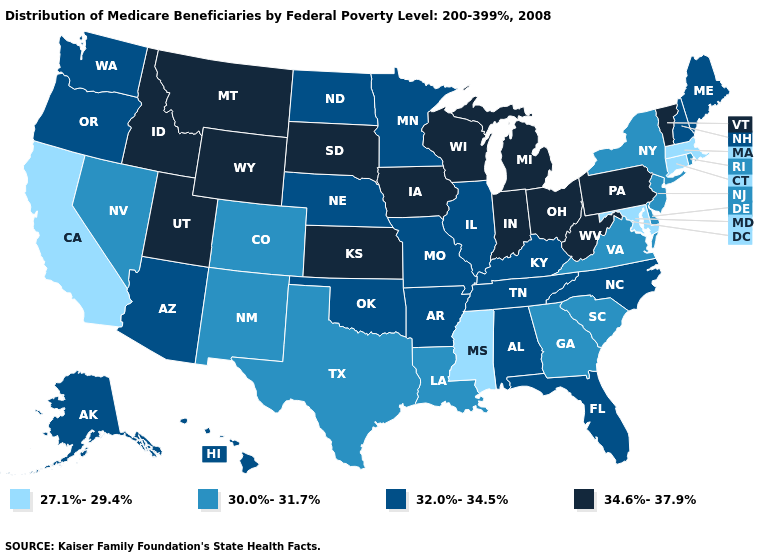What is the value of California?
Quick response, please. 27.1%-29.4%. Does Colorado have the highest value in the West?
Keep it brief. No. Which states have the lowest value in the USA?
Be succinct. California, Connecticut, Maryland, Massachusetts, Mississippi. Name the states that have a value in the range 34.6%-37.9%?
Answer briefly. Idaho, Indiana, Iowa, Kansas, Michigan, Montana, Ohio, Pennsylvania, South Dakota, Utah, Vermont, West Virginia, Wisconsin, Wyoming. Name the states that have a value in the range 34.6%-37.9%?
Be succinct. Idaho, Indiana, Iowa, Kansas, Michigan, Montana, Ohio, Pennsylvania, South Dakota, Utah, Vermont, West Virginia, Wisconsin, Wyoming. Name the states that have a value in the range 30.0%-31.7%?
Answer briefly. Colorado, Delaware, Georgia, Louisiana, Nevada, New Jersey, New Mexico, New York, Rhode Island, South Carolina, Texas, Virginia. Is the legend a continuous bar?
Give a very brief answer. No. Which states have the highest value in the USA?
Concise answer only. Idaho, Indiana, Iowa, Kansas, Michigan, Montana, Ohio, Pennsylvania, South Dakota, Utah, Vermont, West Virginia, Wisconsin, Wyoming. Which states have the highest value in the USA?
Be succinct. Idaho, Indiana, Iowa, Kansas, Michigan, Montana, Ohio, Pennsylvania, South Dakota, Utah, Vermont, West Virginia, Wisconsin, Wyoming. Does the map have missing data?
Short answer required. No. What is the lowest value in the South?
Write a very short answer. 27.1%-29.4%. Does Oregon have the highest value in the West?
Keep it brief. No. What is the value of Michigan?
Quick response, please. 34.6%-37.9%. Name the states that have a value in the range 32.0%-34.5%?
Keep it brief. Alabama, Alaska, Arizona, Arkansas, Florida, Hawaii, Illinois, Kentucky, Maine, Minnesota, Missouri, Nebraska, New Hampshire, North Carolina, North Dakota, Oklahoma, Oregon, Tennessee, Washington. What is the value of North Dakota?
Answer briefly. 32.0%-34.5%. 